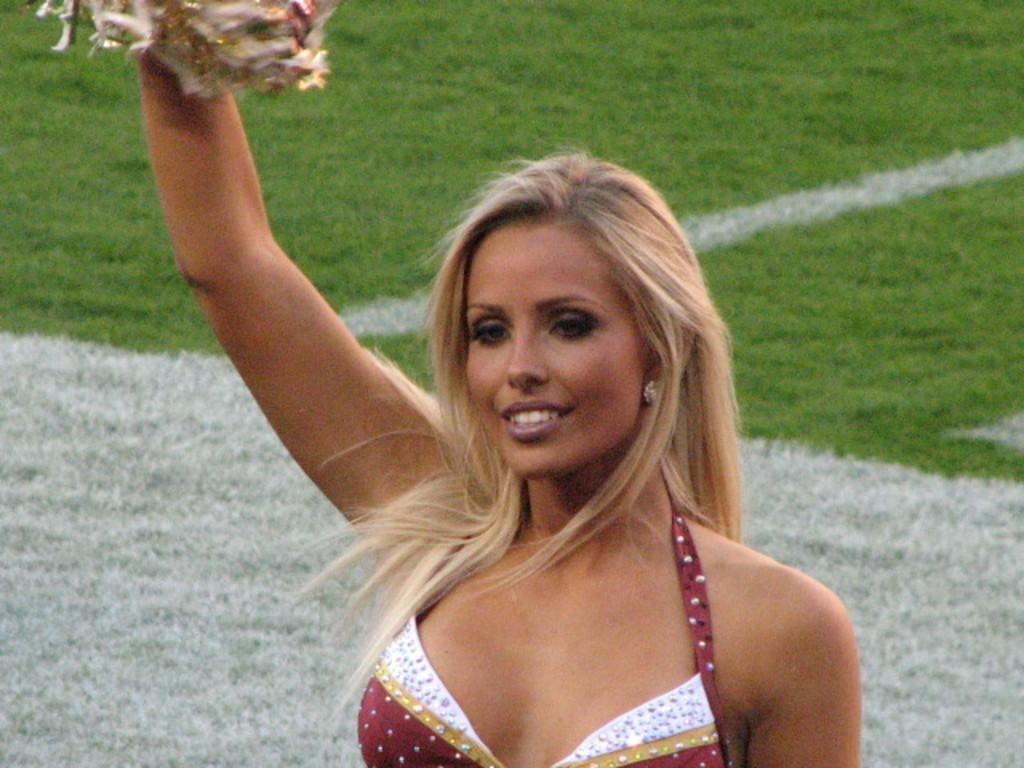Who is the main subject in the image? There is a woman in the image. What is the woman holding in her hand? The woman is holding an object in her hand. Can you describe the background of the image? The background of the image is green and white colored. What level of cheese can be seen on the woman's head in the image? There is no cheese present in the image, and the woman's head is not mentioned in the facts. 